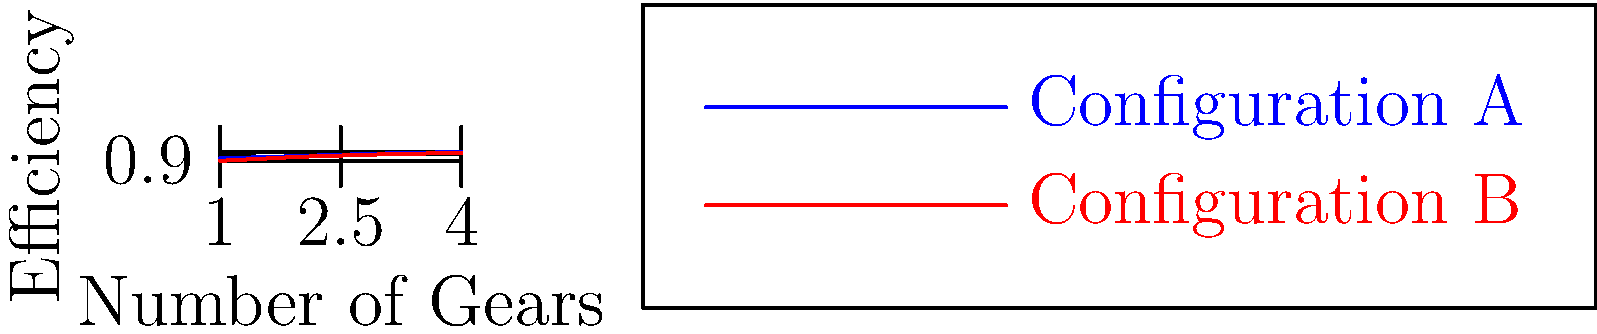As we recall from our work with Sadao Matsubara on transmission systems, efficiency often increases with the number of gears. Based on the graph showing two gear configurations, what is the difference in efficiency between Configuration A and Configuration B when using 3 gears? To solve this problem, we need to follow these steps:

1. Identify the efficiency values for Configuration A and Configuration B at 3 gears:
   - For Configuration A (blue line), the efficiency at 3 gears is 0.91
   - For Configuration B (red line), the efficiency at 3 gears is 0.90

2. Calculate the difference in efficiency:
   $$ \text{Difference} = \text{Efficiency}_A - \text{Efficiency}_B $$
   $$ \text{Difference} = 0.91 - 0.90 = 0.01 $$

3. Convert the difference to a percentage:
   $$ \text{Percentage Difference} = 0.01 \times 100\% = 1\% $$

Therefore, the difference in efficiency between Configuration A and Configuration B when using 3 gears is 1%.
Answer: 1% 